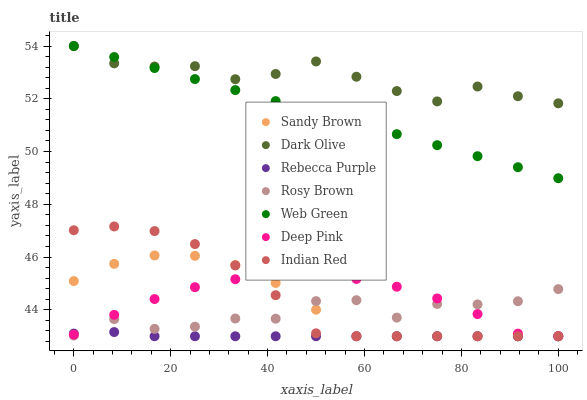Does Rebecca Purple have the minimum area under the curve?
Answer yes or no. Yes. Does Dark Olive have the maximum area under the curve?
Answer yes or no. Yes. Does Rosy Brown have the minimum area under the curve?
Answer yes or no. No. Does Rosy Brown have the maximum area under the curve?
Answer yes or no. No. Is Web Green the smoothest?
Answer yes or no. Yes. Is Rosy Brown the roughest?
Answer yes or no. Yes. Is Rosy Brown the smoothest?
Answer yes or no. No. Is Web Green the roughest?
Answer yes or no. No. Does Deep Pink have the lowest value?
Answer yes or no. Yes. Does Rosy Brown have the lowest value?
Answer yes or no. No. Does Web Green have the highest value?
Answer yes or no. Yes. Does Rosy Brown have the highest value?
Answer yes or no. No. Is Indian Red less than Dark Olive?
Answer yes or no. Yes. Is Dark Olive greater than Indian Red?
Answer yes or no. Yes. Does Rosy Brown intersect Rebecca Purple?
Answer yes or no. Yes. Is Rosy Brown less than Rebecca Purple?
Answer yes or no. No. Is Rosy Brown greater than Rebecca Purple?
Answer yes or no. No. Does Indian Red intersect Dark Olive?
Answer yes or no. No. 